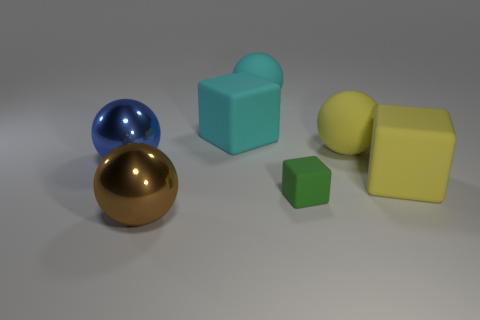Subtract 1 cubes. How many cubes are left? 2 Subtract all purple balls. Subtract all purple cylinders. How many balls are left? 4 Add 2 yellow things. How many objects exist? 9 Subtract all balls. How many objects are left? 3 Add 7 big yellow things. How many big yellow things are left? 9 Add 3 tiny cyan metallic cubes. How many tiny cyan metallic cubes exist? 3 Subtract 1 cyan balls. How many objects are left? 6 Subtract all tiny gray matte cylinders. Subtract all tiny green blocks. How many objects are left? 6 